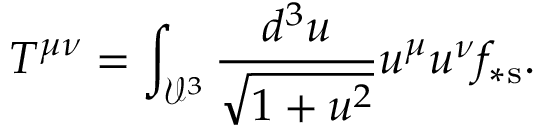Convert formula to latex. <formula><loc_0><loc_0><loc_500><loc_500>T ^ { \mu \nu } = \int _ { \mathcal { V } ^ { 3 } } \frac { d ^ { 3 } u } { \sqrt { 1 + u ^ { 2 } } } u ^ { \mu } u ^ { \nu } f _ { \ast s } .</formula> 